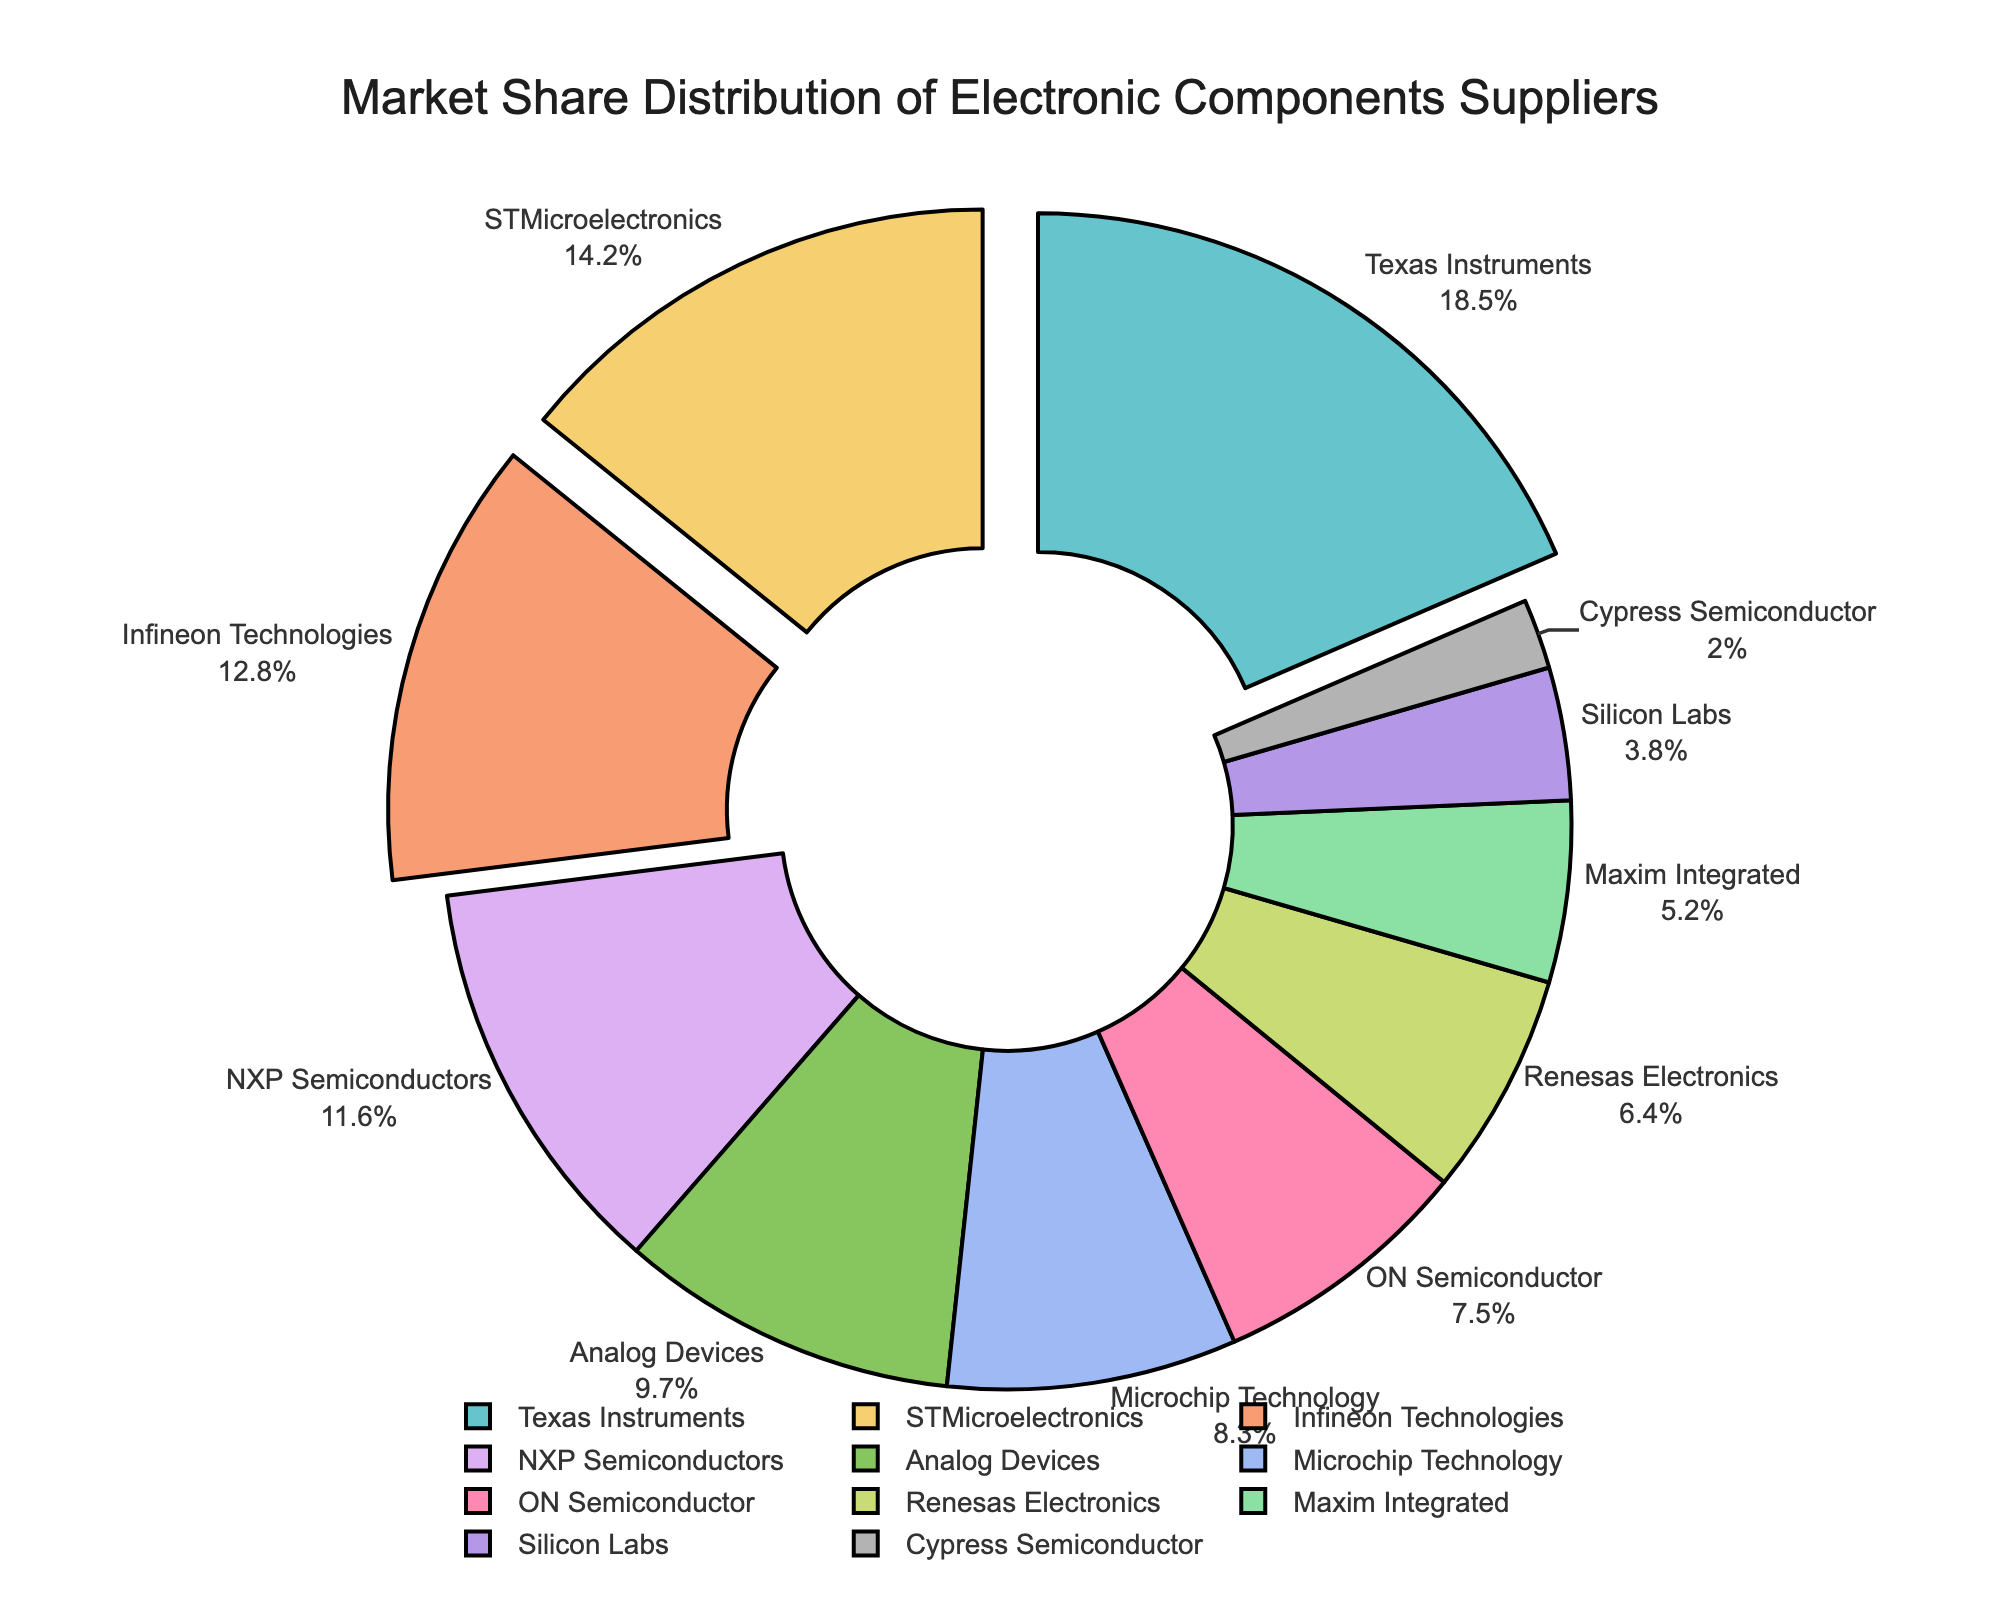What is the market share percentage of STMicroelectronics? Look for STMicroelectronics in the figure and read its corresponding market share percentage.
Answer: 14.2% Which company has the smallest market share, and what is its percentage? Identify the company with the smallest slice in the pie chart and read its label for the market share percentage.
Answer: Cypress Semiconductor, 2.0% How does the market share of Texas Instruments compare to that of NXP Semiconductors? Find Texas Instruments and NXP Semiconductors in the pie chart, then note their respective market share percentages.
Answer: Texas Instruments' market share is higher (18.5%) compared to NXP Semiconductors (11.6%) What is the combined market share of Infineon Technologies and ON Semiconductor? Locate Infineon Technologies and ON Semiconductor in the pie chart, then sum their market shares: 12.8% + 7.5%.
Answer: 20.3% By how much does the market share of Analog Devices exceed that of Silicon Labs? Find Analog Devices' and Silicon Labs' market shares in the pie chart, then subtract Silicon Labs' percentage from Analog Devices': 9.7% - 3.8%.
Answer: 5.9% List the top three companies by market share and their combined percentage. Identify the top three companies (Texas Instruments, STMicroelectronics, Infineon Technologies) in the pie chart and sum their market shares: 18.5% + 14.2% + 12.8%.
Answer: Texas Instruments, STMicroelectronics, Infineon Technologies; 45.5% Who are the companies with a market share between 5% and 10%? Examine the pie chart for companies with market shares within the specified range (5% to 10%).
Answer: Analog Devices, Microchip Technology, ON Semiconductor, Maxim Integrated What is the average market share of the companies shown in the pie chart? Sum the market shares of all companies and divide by the number of companies: (18.5 + 14.2 + 12.8 + 11.6 + 9.7 + 8.3 + 7.5 + 6.4 + 5.2 + 3.8 + 2.0) / 11.
Answer: 9.1% What is the visual importance of the top three companies in the chart? The top three companies have their pie slices visually pulled out from the rest, emphasizing their importance and larger market shares.
Answer: Emphasized by being pulled out 